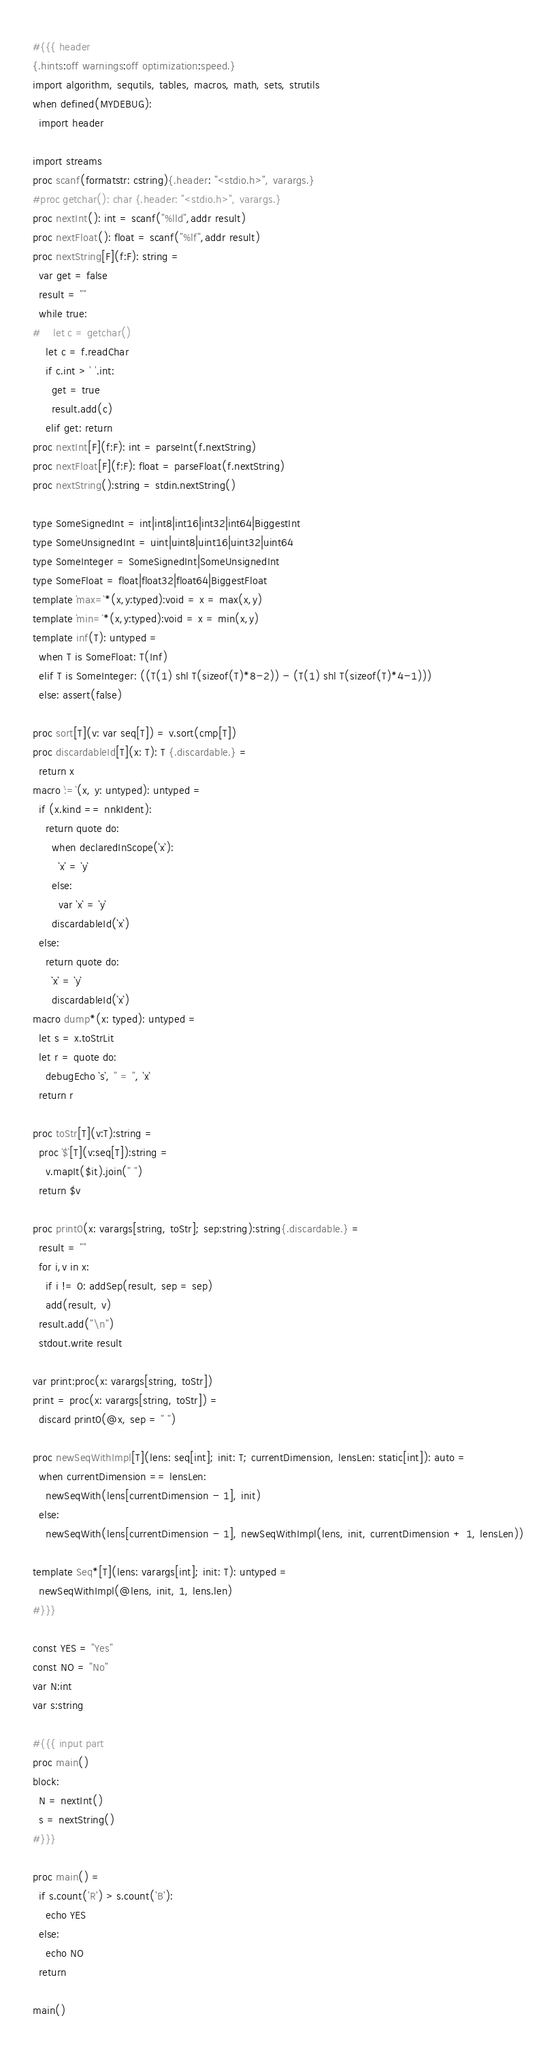<code> <loc_0><loc_0><loc_500><loc_500><_Nim_>#{{{ header
{.hints:off warnings:off optimization:speed.}
import algorithm, sequtils, tables, macros, math, sets, strutils
when defined(MYDEBUG):
  import header

import streams
proc scanf(formatstr: cstring){.header: "<stdio.h>", varargs.}
#proc getchar(): char {.header: "<stdio.h>", varargs.}
proc nextInt(): int = scanf("%lld",addr result)
proc nextFloat(): float = scanf("%lf",addr result)
proc nextString[F](f:F): string =
  var get = false
  result = ""
  while true:
#    let c = getchar()
    let c = f.readChar
    if c.int > ' '.int:
      get = true
      result.add(c)
    elif get: return
proc nextInt[F](f:F): int = parseInt(f.nextString)
proc nextFloat[F](f:F): float = parseFloat(f.nextString)
proc nextString():string = stdin.nextString()

type SomeSignedInt = int|int8|int16|int32|int64|BiggestInt
type SomeUnsignedInt = uint|uint8|uint16|uint32|uint64
type SomeInteger = SomeSignedInt|SomeUnsignedInt
type SomeFloat = float|float32|float64|BiggestFloat
template `max=`*(x,y:typed):void = x = max(x,y)
template `min=`*(x,y:typed):void = x = min(x,y)
template inf(T): untyped = 
  when T is SomeFloat: T(Inf)
  elif T is SomeInteger: ((T(1) shl T(sizeof(T)*8-2)) - (T(1) shl T(sizeof(T)*4-1)))
  else: assert(false)

proc sort[T](v: var seq[T]) = v.sort(cmp[T])
proc discardableId[T](x: T): T {.discardable.} =
  return x
macro `:=`(x, y: untyped): untyped =
  if (x.kind == nnkIdent):
    return quote do:
      when declaredInScope(`x`):
        `x` = `y`
      else:
        var `x` = `y`
      discardableId(`x`)
  else:
    return quote do:
      `x` = `y`
      discardableId(`x`)
macro dump*(x: typed): untyped =
  let s = x.toStrLit
  let r = quote do:
    debugEcho `s`, " = ", `x`
  return r

proc toStr[T](v:T):string =
  proc `$`[T](v:seq[T]):string =
    v.mapIt($it).join(" ")
  return $v

proc print0(x: varargs[string, toStr]; sep:string):string{.discardable.} =
  result = ""
  for i,v in x:
    if i != 0: addSep(result, sep = sep)
    add(result, v)
  result.add("\n")
  stdout.write result

var print:proc(x: varargs[string, toStr])
print = proc(x: varargs[string, toStr]) =
  discard print0(@x, sep = " ")

proc newSeqWithImpl[T](lens: seq[int]; init: T; currentDimension, lensLen: static[int]): auto =
  when currentDimension == lensLen:
    newSeqWith(lens[currentDimension - 1], init)
  else:
    newSeqWith(lens[currentDimension - 1], newSeqWithImpl(lens, init, currentDimension + 1, lensLen))

template Seq*[T](lens: varargs[int]; init: T): untyped =
  newSeqWithImpl(@lens, init, 1, lens.len)
#}}}

const YES = "Yes"
const NO = "No"
var N:int
var s:string

#{{{ input part
proc main()
block:
  N = nextInt()
  s = nextString()
#}}}

proc main() =
  if s.count('R') > s.count('B'):
    echo YES
  else:
    echo NO
  return

main()
</code> 